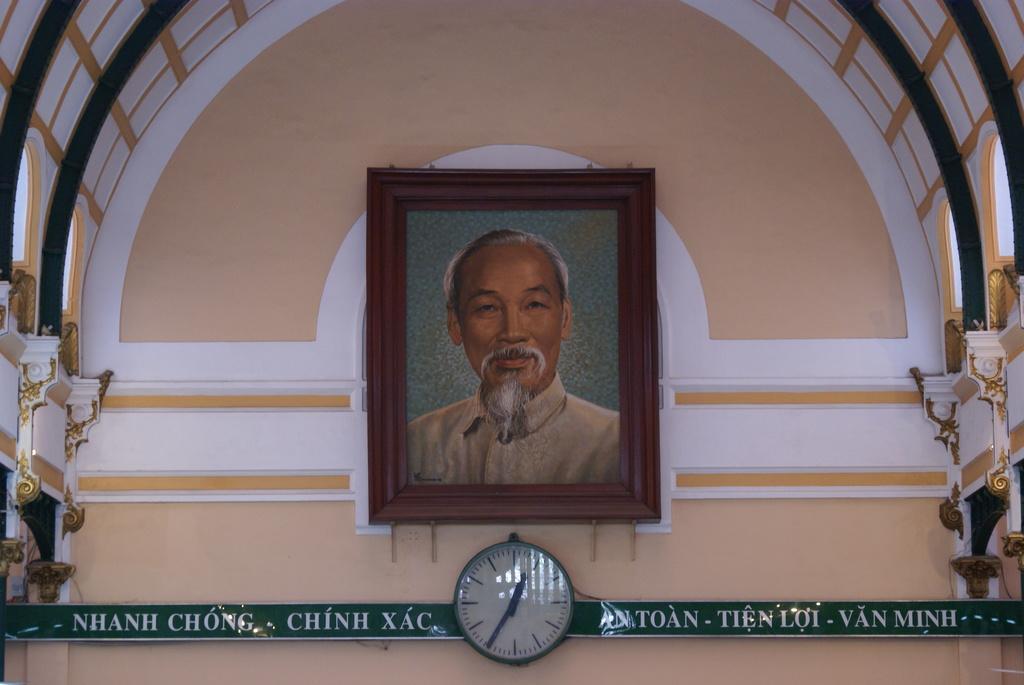In one or two sentences, can you explain what this image depicts? In the picture I can see the photo frame on the wall and it is in the middle of the image. I can see the clock on the wall at the bottom of the picture. I can see the arch design construction at the top of the image. 